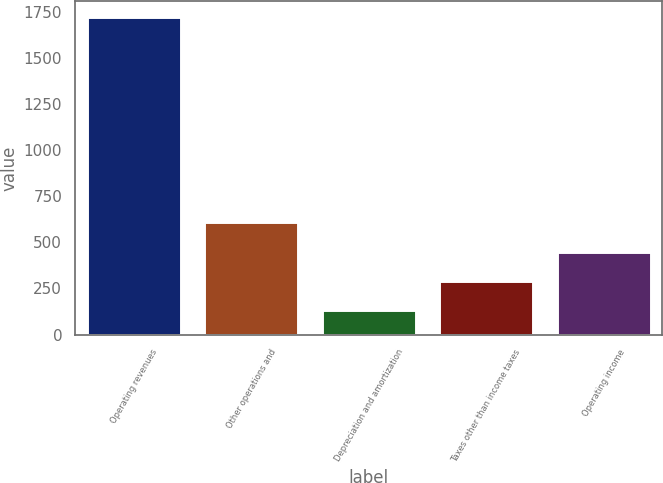Convert chart. <chart><loc_0><loc_0><loc_500><loc_500><bar_chart><fcel>Operating revenues<fcel>Other operations and<fcel>Depreciation and amortization<fcel>Taxes other than income taxes<fcel>Operating income<nl><fcel>1721<fcel>608.7<fcel>132<fcel>290.9<fcel>449.8<nl></chart> 